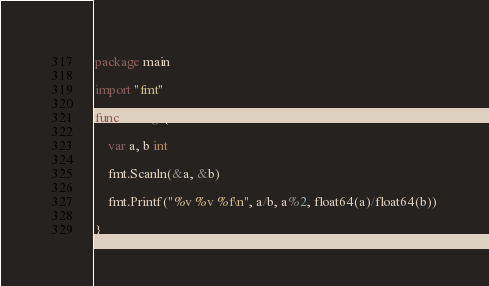Convert code to text. <code><loc_0><loc_0><loc_500><loc_500><_Go_>package main

import "fmt"

func main() {

	var a, b int

	fmt.Scanln(&a, &b)

	fmt.Printf("%v %v %f\n", a/b, a%2, float64(a)/float64(b))

}

</code> 